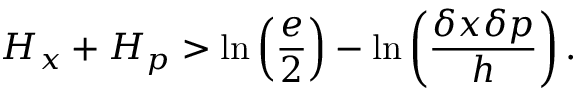<formula> <loc_0><loc_0><loc_500><loc_500>H _ { x } + H _ { p } > \ln \left ( { \frac { e } { 2 } } \right ) - \ln \left ( { \frac { \delta x \delta p } { h } } \right ) .</formula> 